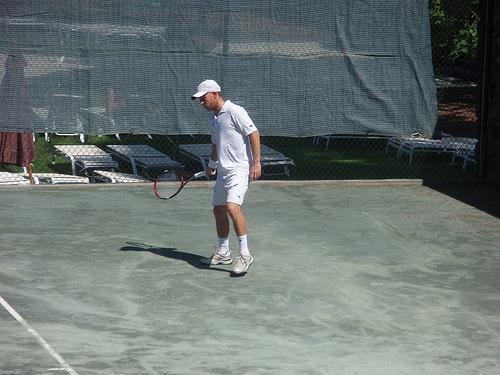How many people are in the photo?
Give a very brief answer. 1. 